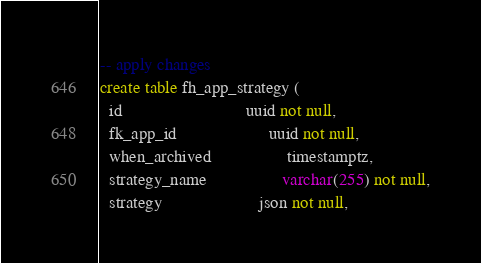<code> <loc_0><loc_0><loc_500><loc_500><_SQL_>-- apply changes
create table fh_app_strategy (
  id                            uuid not null,
  fk_app_id                     uuid not null,
  when_archived                 timestamptz,
  strategy_name                 varchar(255) not null,
  strategy                      json not null,</code> 